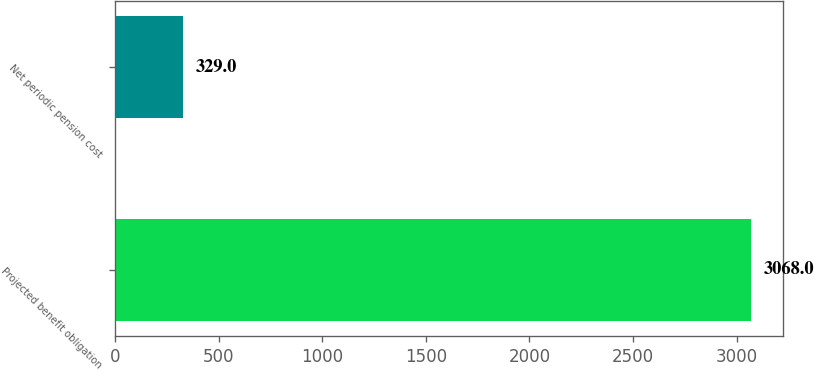Convert chart. <chart><loc_0><loc_0><loc_500><loc_500><bar_chart><fcel>Projected benefit obligation<fcel>Net periodic pension cost<nl><fcel>3068<fcel>329<nl></chart> 